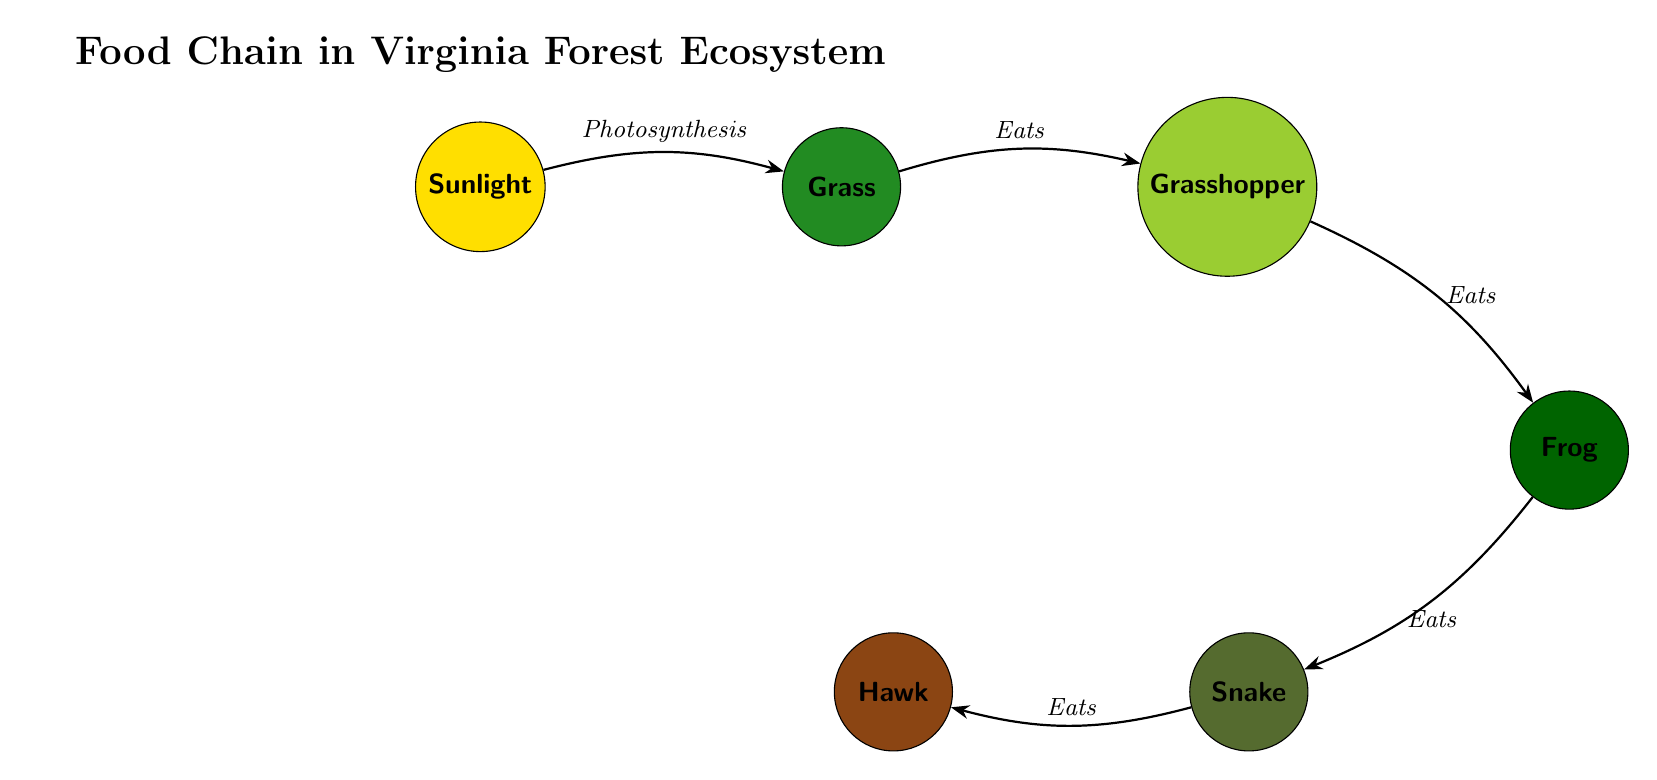What is the first element in the food chain? The first element in the food chain as represented in the diagram is "Sunlight". It is the starting point that provides energy for the other organisms in the ecosystem.
Answer: Sunlight How many organisms are present in the food chain diagram? The food chain contains a total of 6 organisms: Sunlight, Grass, Grasshopper, Frog, Snake, and Hawk. Counting each, we find there are six distinct organisms represented.
Answer: 6 What role does the Grasshopper have in the food chain? The Grasshopper is depicted as eating Grass, indicating its role as a primary consumer in the food chain. It directly feeds on the producer, which is Grass.
Answer: Eats Which organism is at the top of the food chain? The top organism in the food chain is the Hawk, as it preys on the Snake, which is the last consumer before it in the chain. This shows its position as a predator in the ecosystem hierarchy.
Answer: Hawk What does the Snake eat according to the diagram? The diagram shows that the Snake consumes the Frog. This establishes the Snake as a secondary consumer, preying on an organism lower in the food chain.
Answer: Frog If the Grass produces 100 units of energy, how much energy does the Hawk presumably receive? The energy transfer through the food chain follows a general trend where each level receives about 10% of the energy from the previous level. Starting with 100 units of energy in Grass, the Grasshopper gets 10 units, the Frog receives 1 unit, and the Snake gets 0.1 units, while the Hawk would receive 0.01 units. Thus, the Hawk’s energy is calculated as such: 100 (Grass) → 10 (Grasshopper) → 1 (Frog) → 0.1 (Snake) → 0.01 (Hawk).
Answer: 0.01 What is the flow direction from Grass to Grasshopper? The flow from Grass to Grasshopper is indicated by a directed edge labeled "Eats". This relationship signifies that the Grasshopper consumes the Grass, establishing the predator-prey dynamic between these two organisms.
Answer: Eats How many flows are illustrated in the diagram? The diagram features a total of 5 flows, with each one showing a directional relationship between two organisms in the food chain. By counting each directed edge in the diagram, we confirm the total number of flows.
Answer: 5 